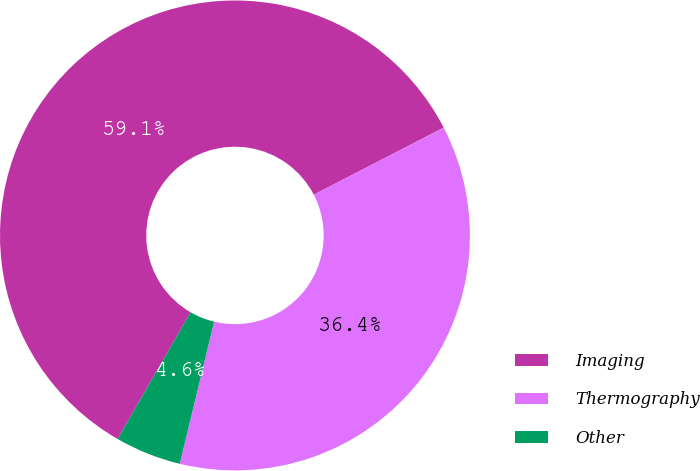<chart> <loc_0><loc_0><loc_500><loc_500><pie_chart><fcel>Imaging<fcel>Thermography<fcel>Other<nl><fcel>59.09%<fcel>36.36%<fcel>4.55%<nl></chart> 